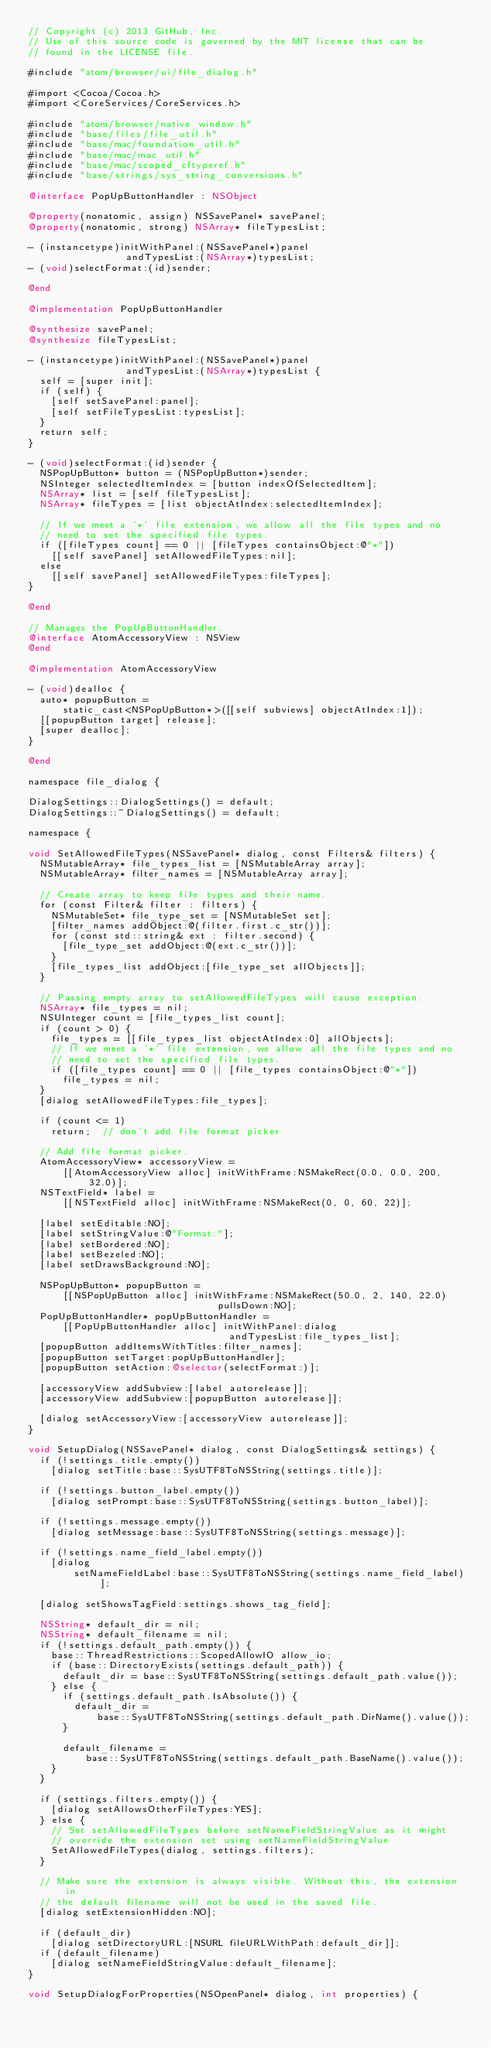<code> <loc_0><loc_0><loc_500><loc_500><_ObjectiveC_>// Copyright (c) 2013 GitHub, Inc.
// Use of this source code is governed by the MIT license that can be
// found in the LICENSE file.

#include "atom/browser/ui/file_dialog.h"

#import <Cocoa/Cocoa.h>
#import <CoreServices/CoreServices.h>

#include "atom/browser/native_window.h"
#include "base/files/file_util.h"
#include "base/mac/foundation_util.h"
#include "base/mac/mac_util.h"
#include "base/mac/scoped_cftyperef.h"
#include "base/strings/sys_string_conversions.h"

@interface PopUpButtonHandler : NSObject

@property(nonatomic, assign) NSSavePanel* savePanel;
@property(nonatomic, strong) NSArray* fileTypesList;

- (instancetype)initWithPanel:(NSSavePanel*)panel
                 andTypesList:(NSArray*)typesList;
- (void)selectFormat:(id)sender;

@end

@implementation PopUpButtonHandler

@synthesize savePanel;
@synthesize fileTypesList;

- (instancetype)initWithPanel:(NSSavePanel*)panel
                 andTypesList:(NSArray*)typesList {
  self = [super init];
  if (self) {
    [self setSavePanel:panel];
    [self setFileTypesList:typesList];
  }
  return self;
}

- (void)selectFormat:(id)sender {
  NSPopUpButton* button = (NSPopUpButton*)sender;
  NSInteger selectedItemIndex = [button indexOfSelectedItem];
  NSArray* list = [self fileTypesList];
  NSArray* fileTypes = [list objectAtIndex:selectedItemIndex];

  // If we meet a '*' file extension, we allow all the file types and no
  // need to set the specified file types.
  if ([fileTypes count] == 0 || [fileTypes containsObject:@"*"])
    [[self savePanel] setAllowedFileTypes:nil];
  else
    [[self savePanel] setAllowedFileTypes:fileTypes];
}

@end

// Manages the PopUpButtonHandler.
@interface AtomAccessoryView : NSView
@end

@implementation AtomAccessoryView

- (void)dealloc {
  auto* popupButton =
      static_cast<NSPopUpButton*>([[self subviews] objectAtIndex:1]);
  [[popupButton target] release];
  [super dealloc];
}

@end

namespace file_dialog {

DialogSettings::DialogSettings() = default;
DialogSettings::~DialogSettings() = default;

namespace {

void SetAllowedFileTypes(NSSavePanel* dialog, const Filters& filters) {
  NSMutableArray* file_types_list = [NSMutableArray array];
  NSMutableArray* filter_names = [NSMutableArray array];

  // Create array to keep file types and their name.
  for (const Filter& filter : filters) {
    NSMutableSet* file_type_set = [NSMutableSet set];
    [filter_names addObject:@(filter.first.c_str())];
    for (const std::string& ext : filter.second) {
      [file_type_set addObject:@(ext.c_str())];
    }
    [file_types_list addObject:[file_type_set allObjects]];
  }

  // Passing empty array to setAllowedFileTypes will cause exception.
  NSArray* file_types = nil;
  NSUInteger count = [file_types_list count];
  if (count > 0) {
    file_types = [[file_types_list objectAtIndex:0] allObjects];
    // If we meet a '*' file extension, we allow all the file types and no
    // need to set the specified file types.
    if ([file_types count] == 0 || [file_types containsObject:@"*"])
      file_types = nil;
  }
  [dialog setAllowedFileTypes:file_types];

  if (count <= 1)
    return;  // don't add file format picker

  // Add file format picker.
  AtomAccessoryView* accessoryView =
      [[AtomAccessoryView alloc] initWithFrame:NSMakeRect(0.0, 0.0, 200, 32.0)];
  NSTextField* label =
      [[NSTextField alloc] initWithFrame:NSMakeRect(0, 0, 60, 22)];

  [label setEditable:NO];
  [label setStringValue:@"Format:"];
  [label setBordered:NO];
  [label setBezeled:NO];
  [label setDrawsBackground:NO];

  NSPopUpButton* popupButton =
      [[NSPopUpButton alloc] initWithFrame:NSMakeRect(50.0, 2, 140, 22.0)
                                 pullsDown:NO];
  PopUpButtonHandler* popUpButtonHandler =
      [[PopUpButtonHandler alloc] initWithPanel:dialog
                                   andTypesList:file_types_list];
  [popupButton addItemsWithTitles:filter_names];
  [popupButton setTarget:popUpButtonHandler];
  [popupButton setAction:@selector(selectFormat:)];

  [accessoryView addSubview:[label autorelease]];
  [accessoryView addSubview:[popupButton autorelease]];

  [dialog setAccessoryView:[accessoryView autorelease]];
}

void SetupDialog(NSSavePanel* dialog, const DialogSettings& settings) {
  if (!settings.title.empty())
    [dialog setTitle:base::SysUTF8ToNSString(settings.title)];

  if (!settings.button_label.empty())
    [dialog setPrompt:base::SysUTF8ToNSString(settings.button_label)];

  if (!settings.message.empty())
    [dialog setMessage:base::SysUTF8ToNSString(settings.message)];

  if (!settings.name_field_label.empty())
    [dialog
        setNameFieldLabel:base::SysUTF8ToNSString(settings.name_field_label)];

  [dialog setShowsTagField:settings.shows_tag_field];

  NSString* default_dir = nil;
  NSString* default_filename = nil;
  if (!settings.default_path.empty()) {
    base::ThreadRestrictions::ScopedAllowIO allow_io;
    if (base::DirectoryExists(settings.default_path)) {
      default_dir = base::SysUTF8ToNSString(settings.default_path.value());
    } else {
      if (settings.default_path.IsAbsolute()) {
        default_dir =
            base::SysUTF8ToNSString(settings.default_path.DirName().value());
      }

      default_filename =
          base::SysUTF8ToNSString(settings.default_path.BaseName().value());
    }
  }

  if (settings.filters.empty()) {
    [dialog setAllowsOtherFileTypes:YES];
  } else {
    // Set setAllowedFileTypes before setNameFieldStringValue as it might
    // override the extension set using setNameFieldStringValue
    SetAllowedFileTypes(dialog, settings.filters);
  }

  // Make sure the extension is always visible. Without this, the extension in
  // the default filename will not be used in the saved file.
  [dialog setExtensionHidden:NO];

  if (default_dir)
    [dialog setDirectoryURL:[NSURL fileURLWithPath:default_dir]];
  if (default_filename)
    [dialog setNameFieldStringValue:default_filename];
}

void SetupDialogForProperties(NSOpenPanel* dialog, int properties) {</code> 